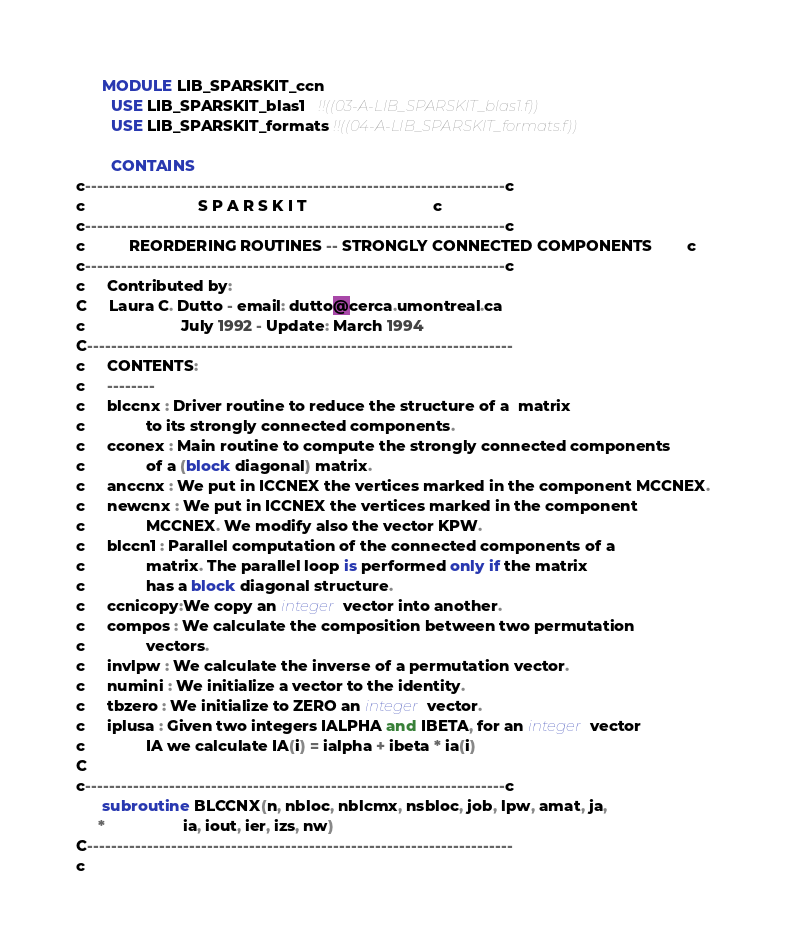<code> <loc_0><loc_0><loc_500><loc_500><_FORTRAN_>      MODULE LIB_SPARSKIT_ccn
        USE LIB_SPARSKIT_blas1   !!((03-A-LIB_SPARSKIT_blas1.f))
        USE LIB_SPARSKIT_formats !!((04-A-LIB_SPARSKIT_formats.f))

        CONTAINS
c----------------------------------------------------------------------c
c                          S P A R S K I T                             c
c----------------------------------------------------------------------c
c          REORDERING ROUTINES -- STRONGLY CONNECTED COMPONENTS        c
c----------------------------------------------------------------------c
c     Contributed by:
C     Laura C. Dutto - email: dutto@cerca.umontreal.ca
c                      July 1992 - Update: March 1994
C-----------------------------------------------------------------------
c     CONTENTS:
c     --------
c     blccnx : Driver routine to reduce the structure of a  matrix
c              to its strongly connected components.
c     cconex : Main routine to compute the strongly connected components
c              of a (block diagonal) matrix.
c     anccnx : We put in ICCNEX the vertices marked in the component MCCNEX.
c     newcnx : We put in ICCNEX the vertices marked in the component
c              MCCNEX. We modify also the vector KPW.
c     blccn1 : Parallel computation of the connected components of a
c              matrix. The parallel loop is performed only if the matrix
c              has a block diagonal structure.
c     ccnicopy:We copy an integer vector into another.
c     compos : We calculate the composition between two permutation
c              vectors.
c     invlpw : We calculate the inverse of a permutation vector.
c     numini : We initialize a vector to the identity.
c     tbzero : We initialize to ZERO an integer vector.
c     iplusa : Given two integers IALPHA and IBETA, for an integer vector
c              IA we calculate IA(i) = ialpha + ibeta * ia(i)
C
c----------------------------------------------------------------------c
      subroutine BLCCNX(n, nbloc, nblcmx, nsbloc, job, lpw, amat, ja,
     *                  ia, iout, ier, izs, nw)
C-----------------------------------------------------------------------
c</code> 